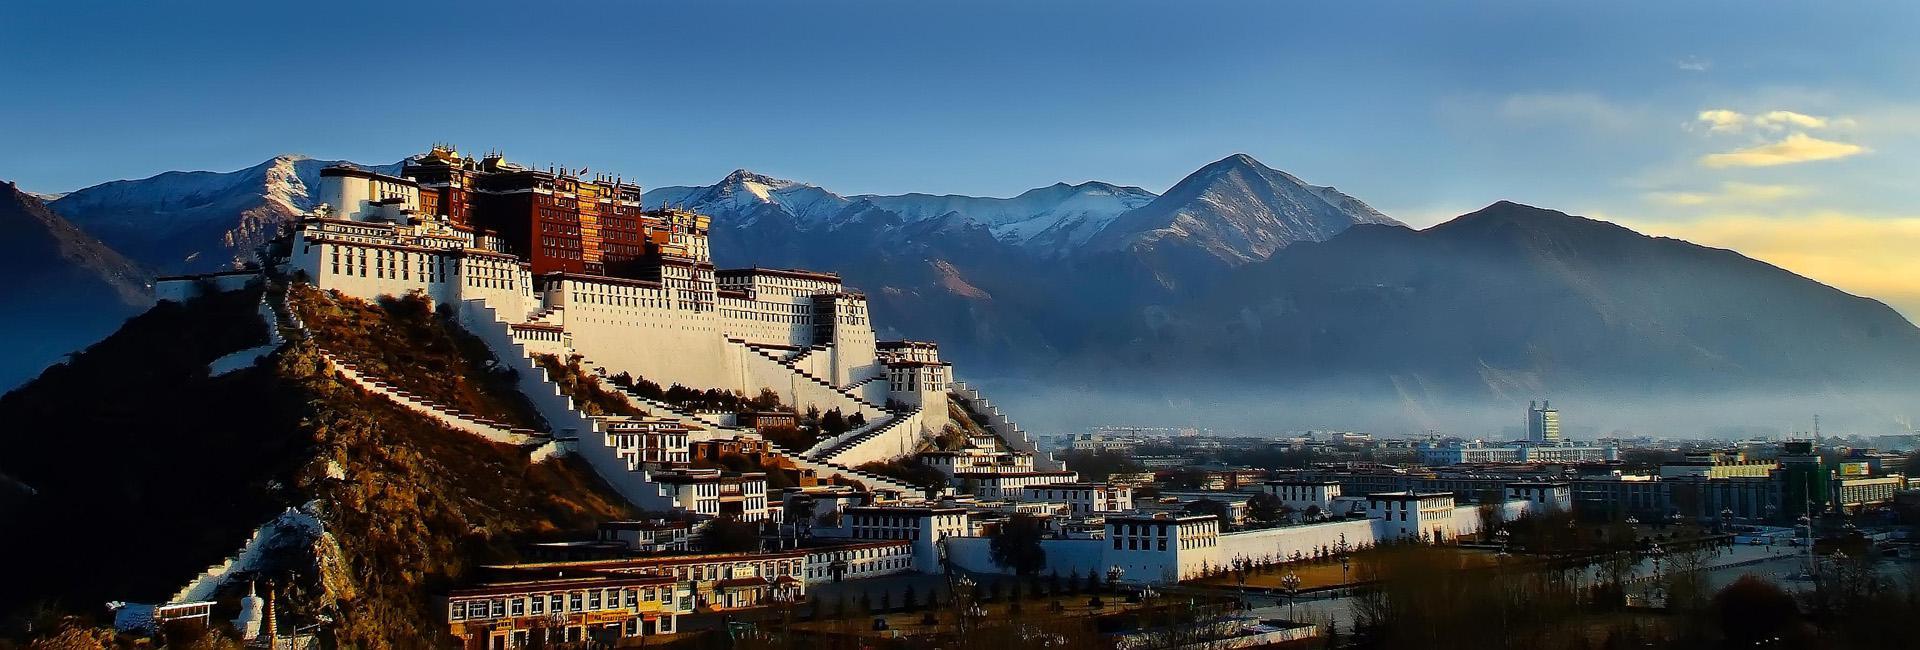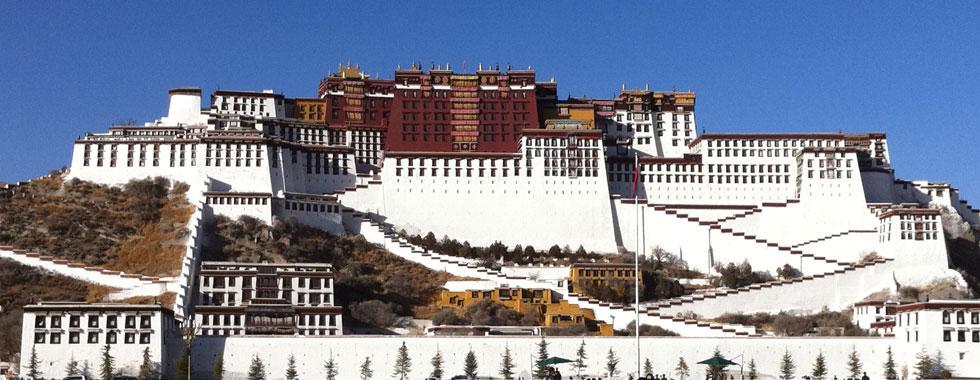The first image is the image on the left, the second image is the image on the right. Evaluate the accuracy of this statement regarding the images: "In at least one image there is a group standing in front of a three story white stari wall that is below four rows of window.". Is it true? Answer yes or no. No. The first image is the image on the left, the second image is the image on the right. Analyze the images presented: Is the assertion "In exactly one image a group of people are posing in front of a structure." valid? Answer yes or no. No. 